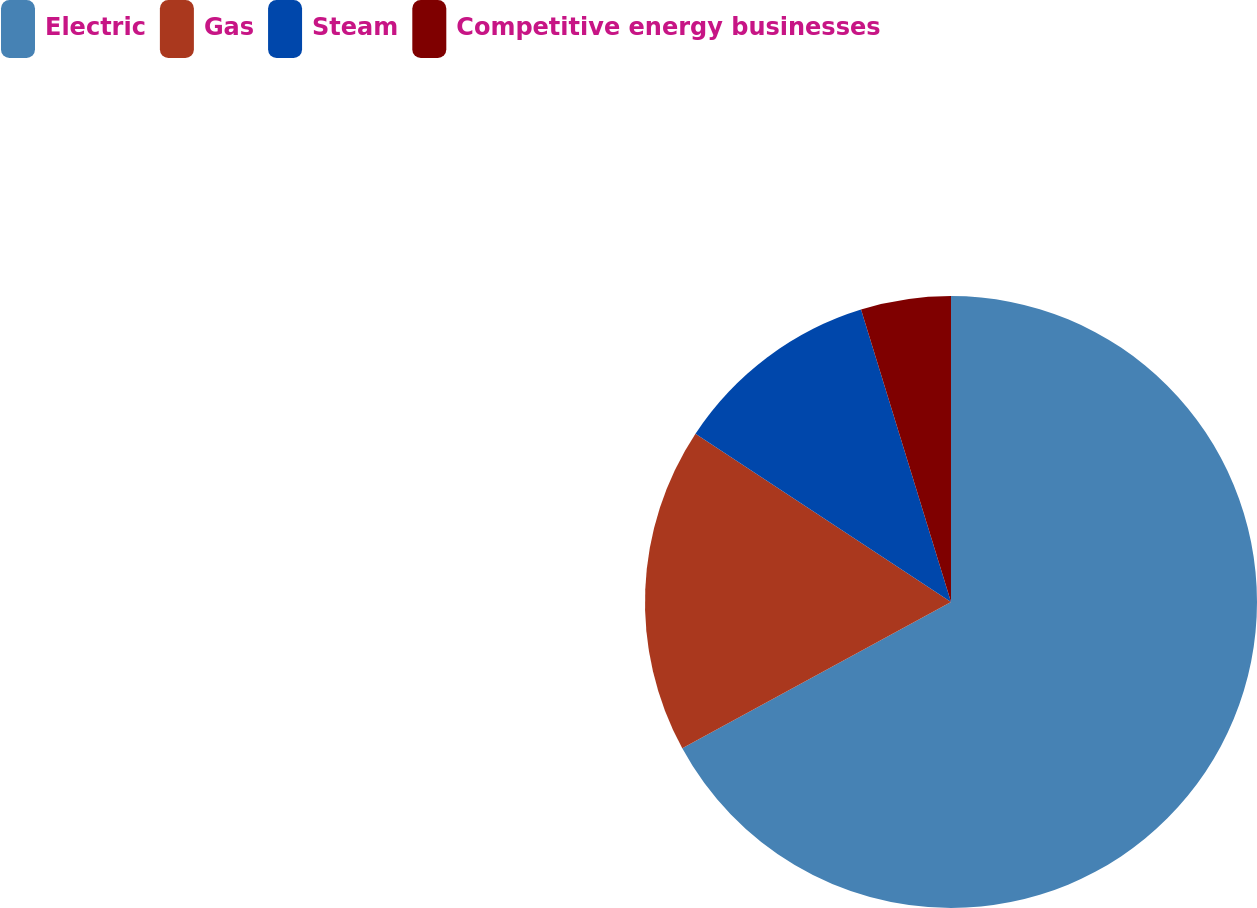Convert chart. <chart><loc_0><loc_0><loc_500><loc_500><pie_chart><fcel>Electric<fcel>Gas<fcel>Steam<fcel>Competitive energy businesses<nl><fcel>67.07%<fcel>17.21%<fcel>10.98%<fcel>4.75%<nl></chart> 